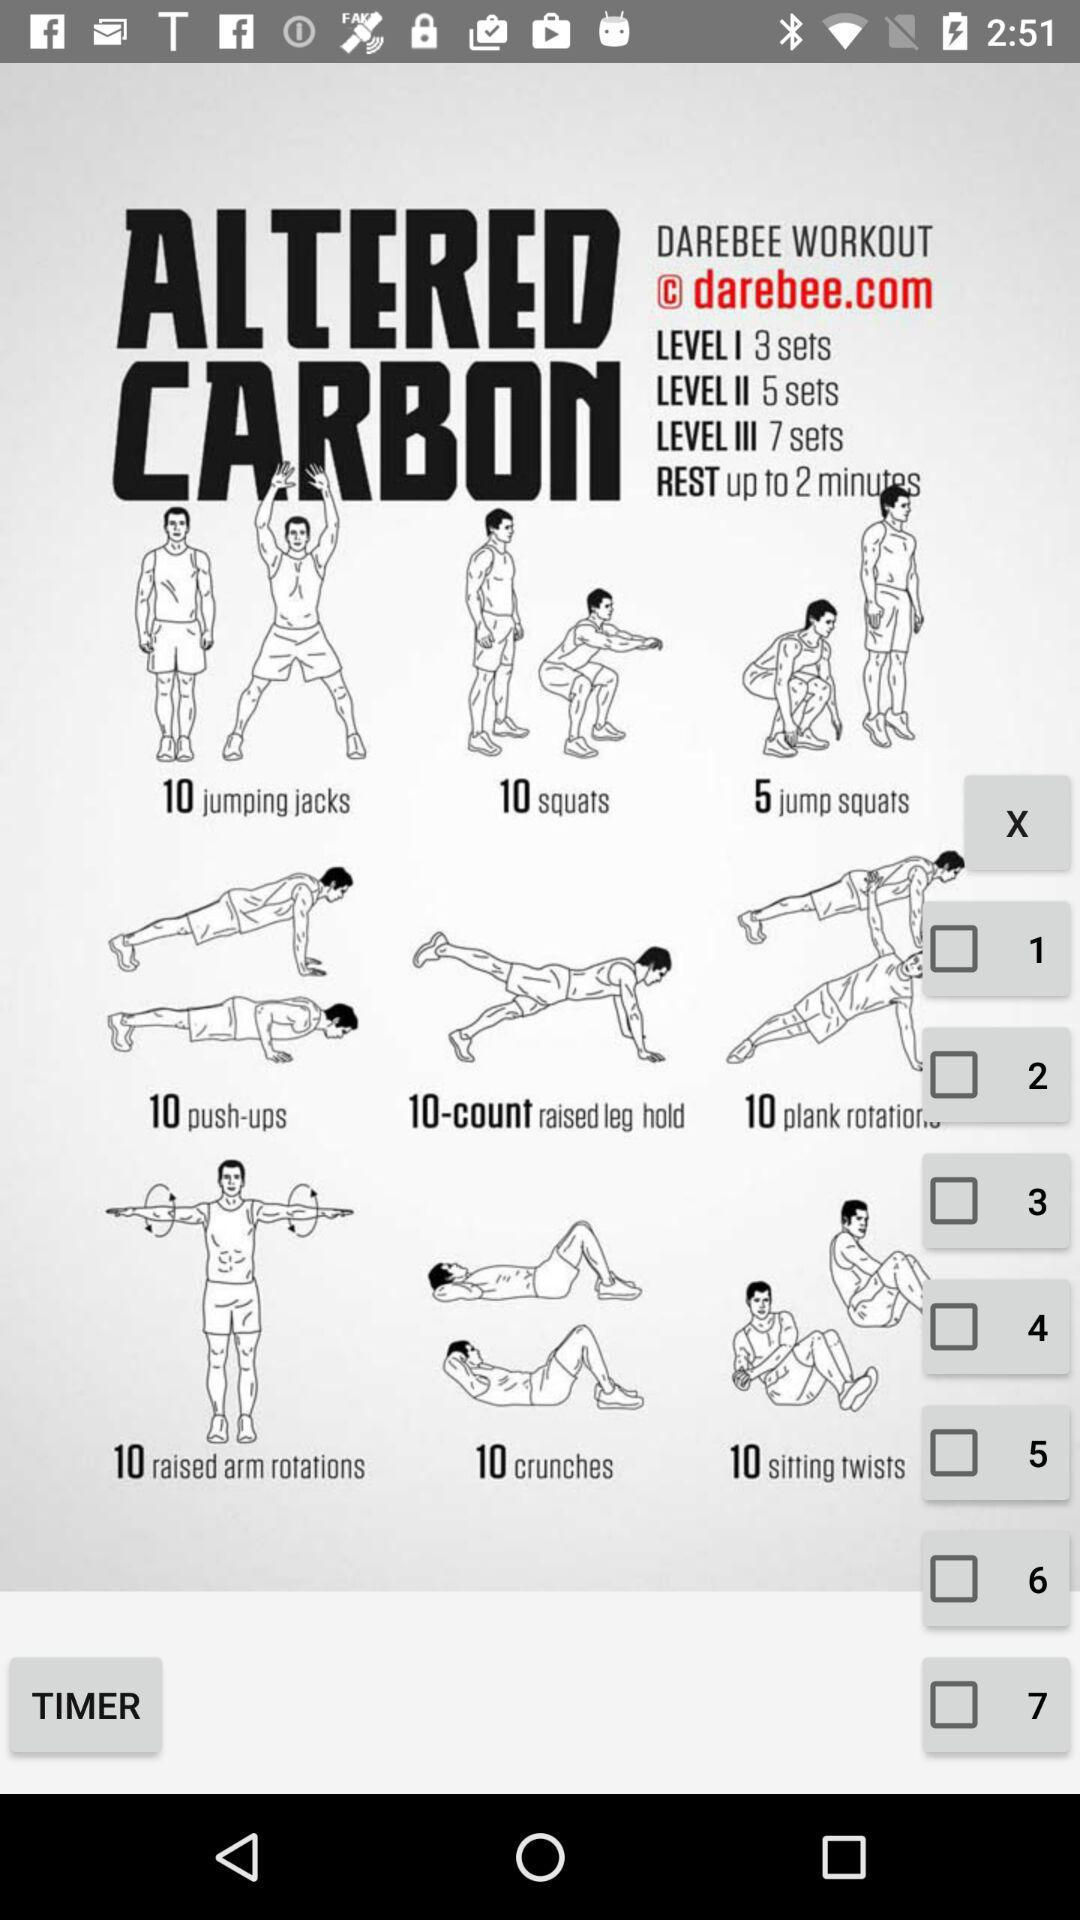What is the rest time? The rest time is up to 2 minutes. 